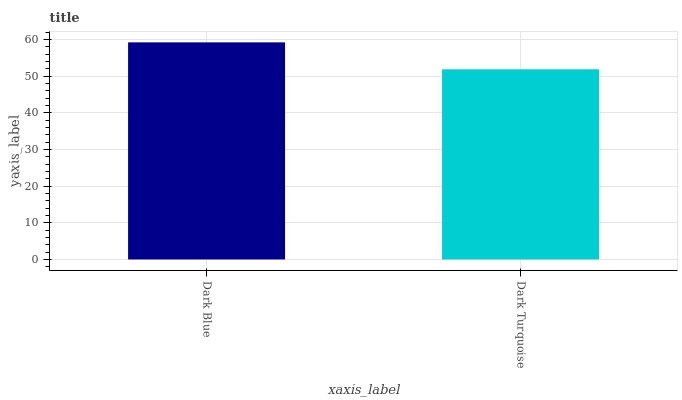Is Dark Turquoise the minimum?
Answer yes or no. Yes. Is Dark Blue the maximum?
Answer yes or no. Yes. Is Dark Turquoise the maximum?
Answer yes or no. No. Is Dark Blue greater than Dark Turquoise?
Answer yes or no. Yes. Is Dark Turquoise less than Dark Blue?
Answer yes or no. Yes. Is Dark Turquoise greater than Dark Blue?
Answer yes or no. No. Is Dark Blue less than Dark Turquoise?
Answer yes or no. No. Is Dark Blue the high median?
Answer yes or no. Yes. Is Dark Turquoise the low median?
Answer yes or no. Yes. Is Dark Turquoise the high median?
Answer yes or no. No. Is Dark Blue the low median?
Answer yes or no. No. 